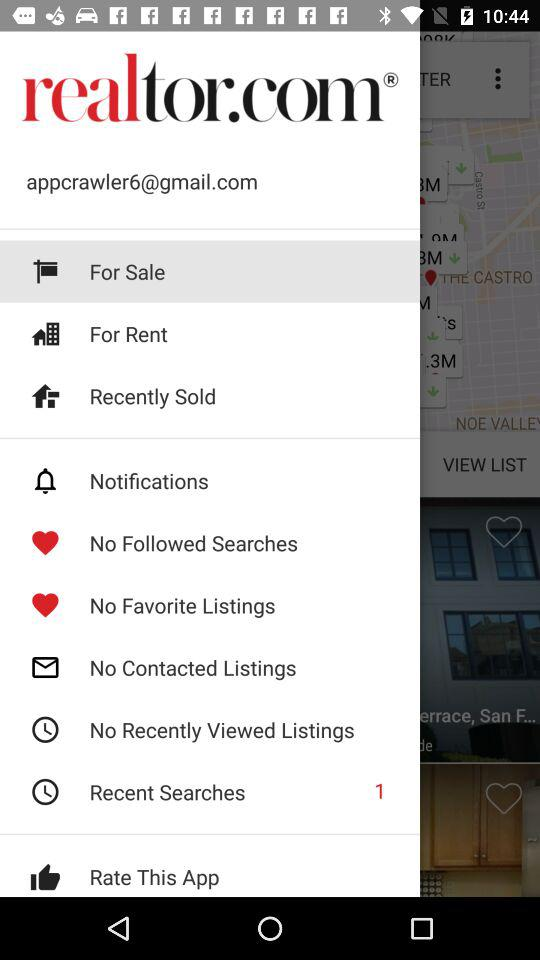What option has been selected? The option that has been selected is "For Sale". 